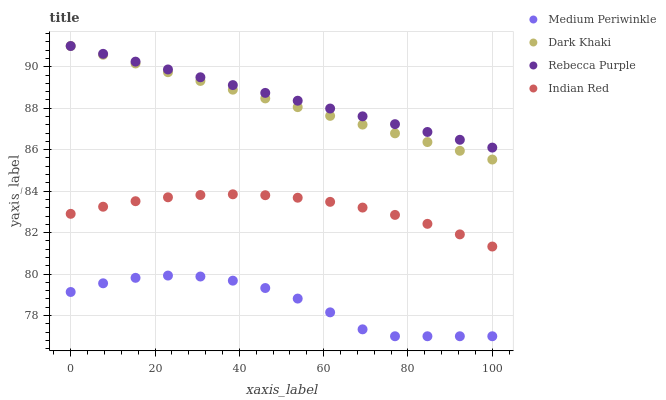Does Medium Periwinkle have the minimum area under the curve?
Answer yes or no. Yes. Does Rebecca Purple have the maximum area under the curve?
Answer yes or no. Yes. Does Rebecca Purple have the minimum area under the curve?
Answer yes or no. No. Does Medium Periwinkle have the maximum area under the curve?
Answer yes or no. No. Is Dark Khaki the smoothest?
Answer yes or no. Yes. Is Medium Periwinkle the roughest?
Answer yes or no. Yes. Is Rebecca Purple the smoothest?
Answer yes or no. No. Is Rebecca Purple the roughest?
Answer yes or no. No. Does Medium Periwinkle have the lowest value?
Answer yes or no. Yes. Does Rebecca Purple have the lowest value?
Answer yes or no. No. Does Rebecca Purple have the highest value?
Answer yes or no. Yes. Does Medium Periwinkle have the highest value?
Answer yes or no. No. Is Medium Periwinkle less than Indian Red?
Answer yes or no. Yes. Is Indian Red greater than Medium Periwinkle?
Answer yes or no. Yes. Does Rebecca Purple intersect Dark Khaki?
Answer yes or no. Yes. Is Rebecca Purple less than Dark Khaki?
Answer yes or no. No. Is Rebecca Purple greater than Dark Khaki?
Answer yes or no. No. Does Medium Periwinkle intersect Indian Red?
Answer yes or no. No. 